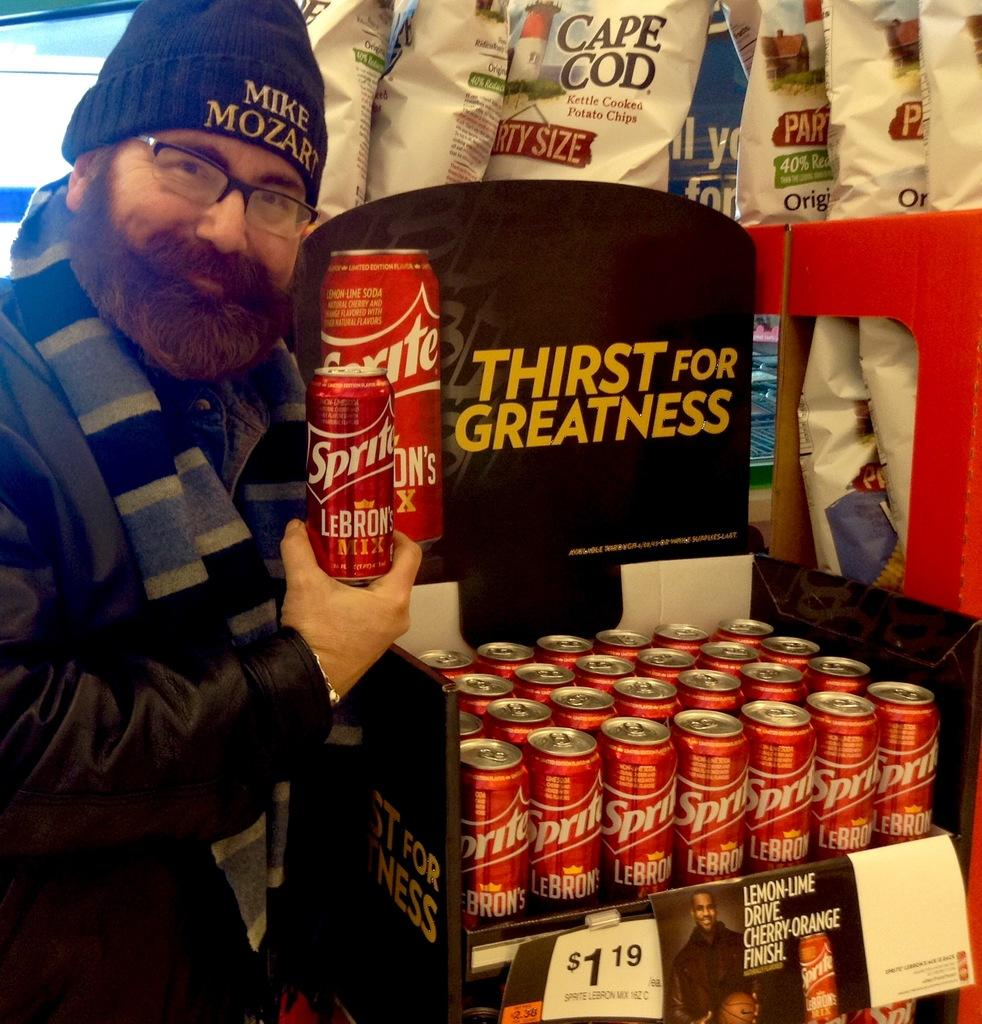<image>
Present a compact description of the photo's key features. Sprite in red cans in a display that says Thirst for Greatness. 